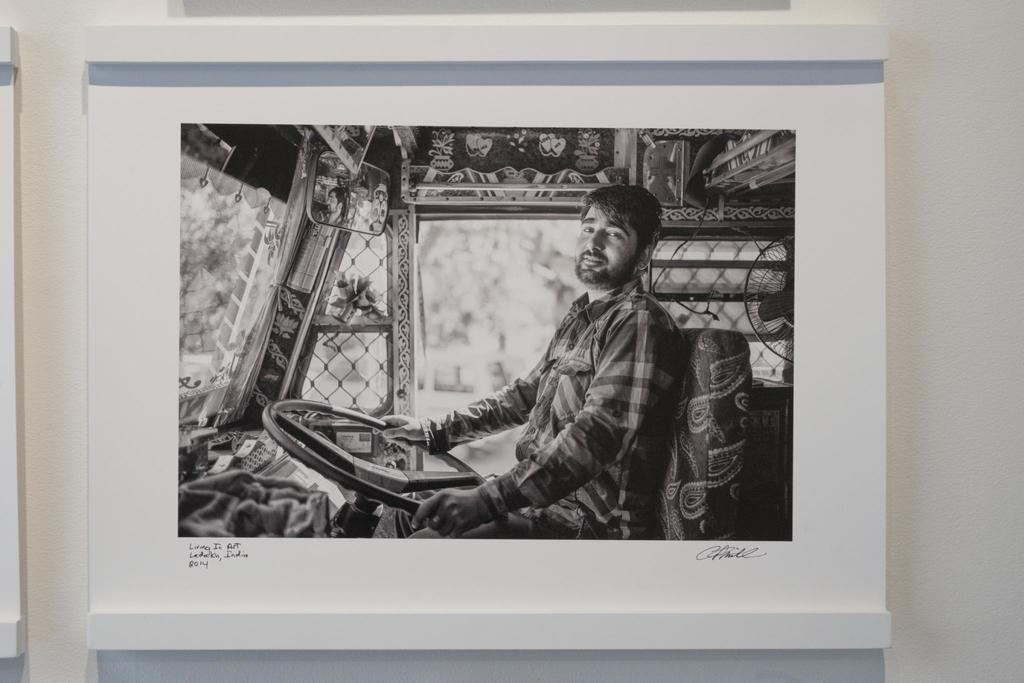In one or two sentences, can you explain what this image depicts? In this image I can see the frame. In the frame I can see the person is sitting on the seat and holding the steering. I can see the mirror and the table-fan. The frame is attached to the white color wall. 